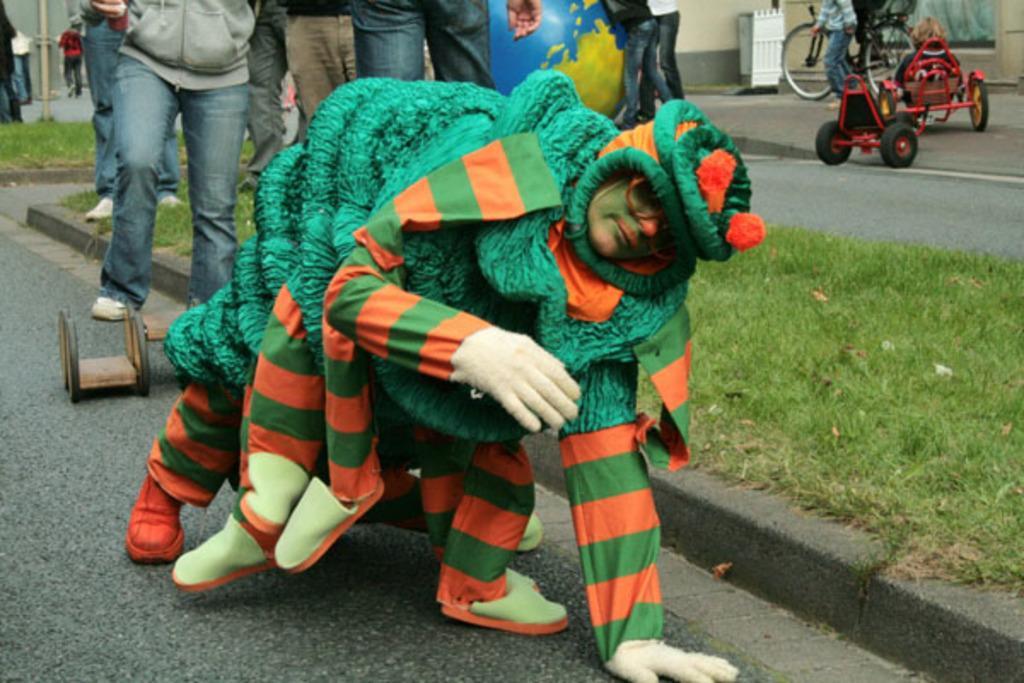In one or two sentences, can you explain what this image depicts? In front of the picture, we see a man is wearing some costume which is in green and orange color. Beside him, we see the grass. Behind him, we see people are standing on the road. Behind them, we see a blue color globe or inflatable balloon. In the right top, we see a vehicle and a man riding the bicycle. Beside that, we see a white box and a wall. In the left top, we see a pole and people walking on the road. At the bottom, we see the road. 